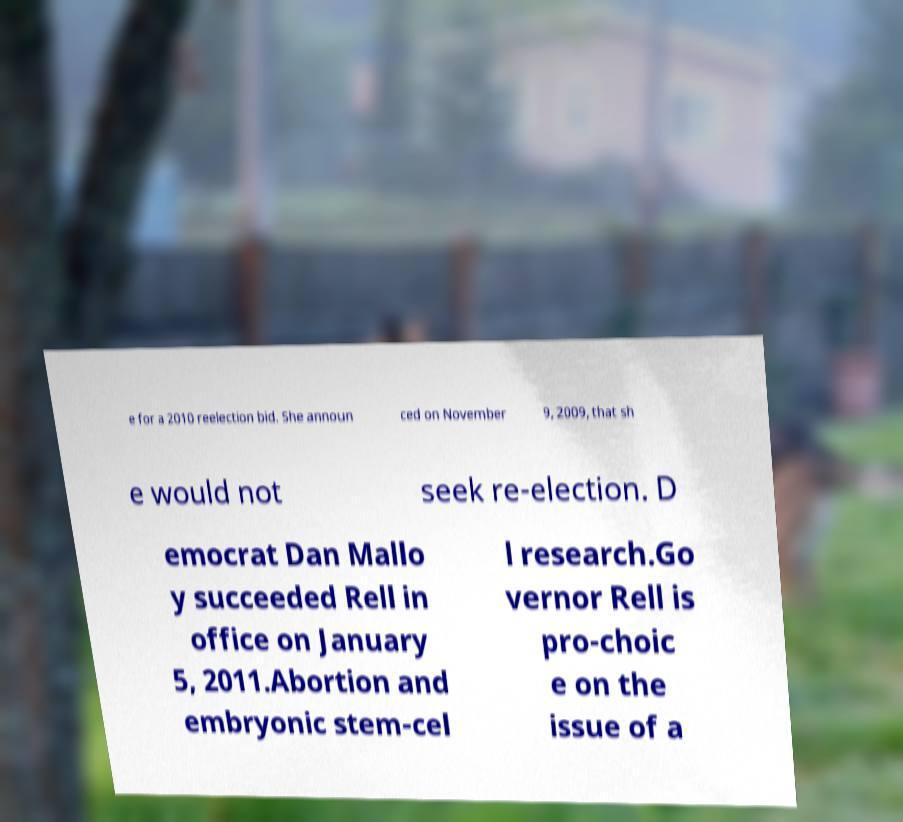Please read and relay the text visible in this image. What does it say? e for a 2010 reelection bid. She announ ced on November 9, 2009, that sh e would not seek re-election. D emocrat Dan Mallo y succeeded Rell in office on January 5, 2011.Abortion and embryonic stem-cel l research.Go vernor Rell is pro-choic e on the issue of a 